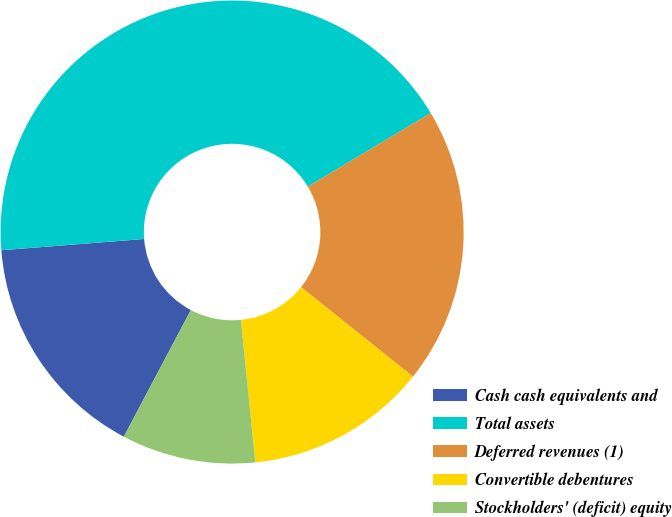<chart> <loc_0><loc_0><loc_500><loc_500><pie_chart><fcel>Cash cash equivalents and<fcel>Total assets<fcel>Deferred revenues (1)<fcel>Convertible debentures<fcel>Stockholders' (deficit) equity<nl><fcel>16.0%<fcel>42.66%<fcel>19.33%<fcel>12.67%<fcel>9.34%<nl></chart> 